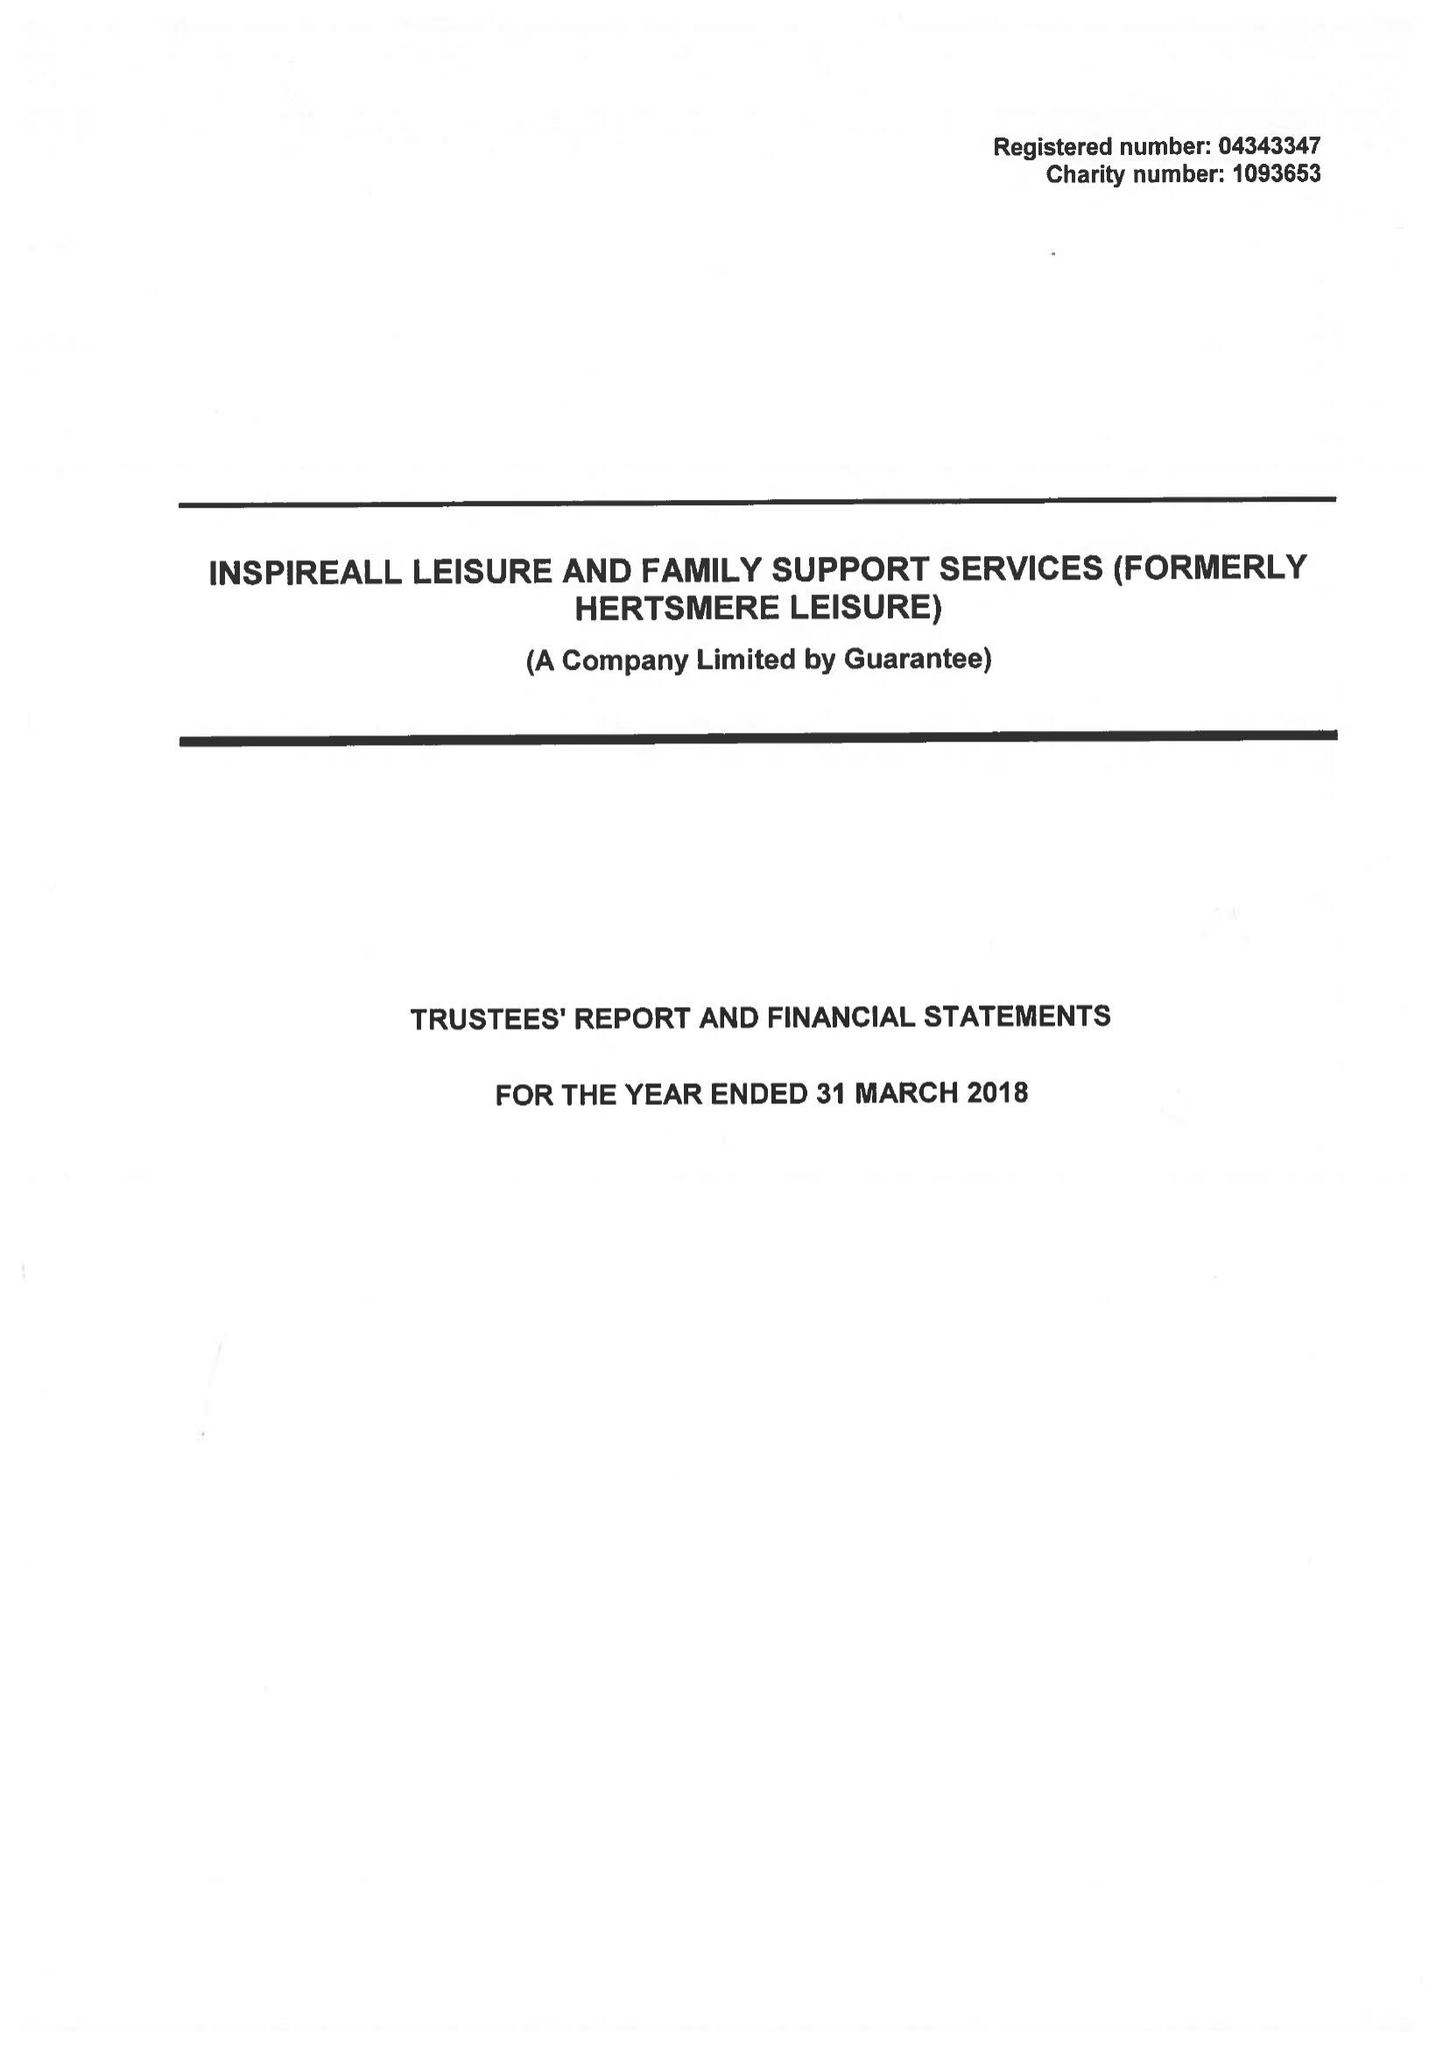What is the value for the spending_annually_in_british_pounds?
Answer the question using a single word or phrase. 19640070.00 